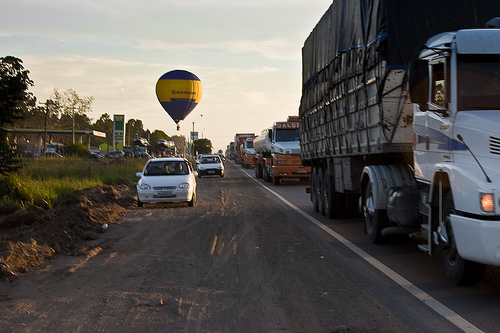<image>
Is there a truck on the street? Yes. Looking at the image, I can see the truck is positioned on top of the street, with the street providing support. 